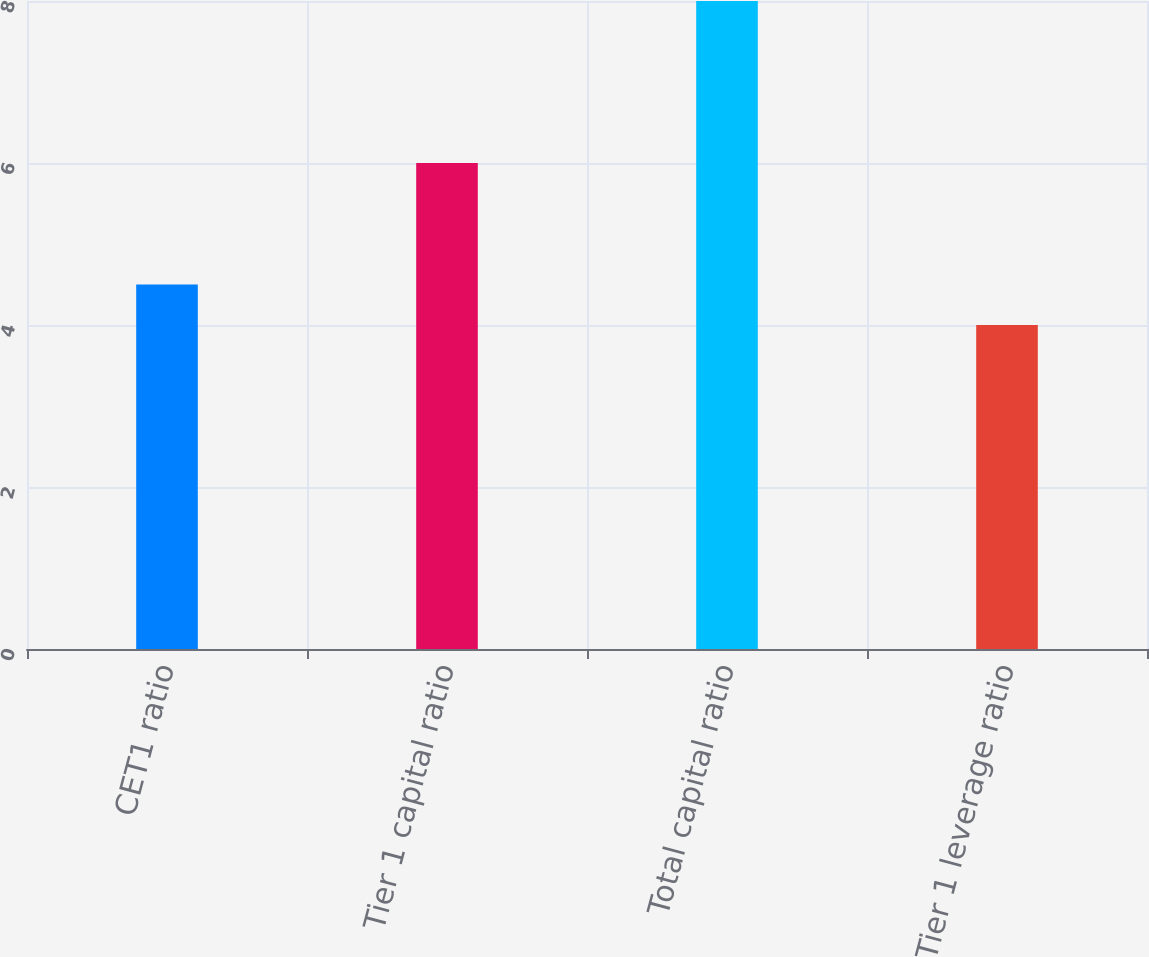Convert chart. <chart><loc_0><loc_0><loc_500><loc_500><bar_chart><fcel>CET1 ratio<fcel>Tier 1 capital ratio<fcel>Total capital ratio<fcel>Tier 1 leverage ratio<nl><fcel>4.5<fcel>6<fcel>8<fcel>4<nl></chart> 